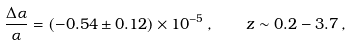<formula> <loc_0><loc_0><loc_500><loc_500>\frac { \Delta \alpha } { \alpha } = ( - 0 . 5 4 \pm 0 . 1 2 ) \times 1 0 ^ { - 5 } \, , \quad z \sim 0 . 2 - 3 . 7 \, ,</formula> 